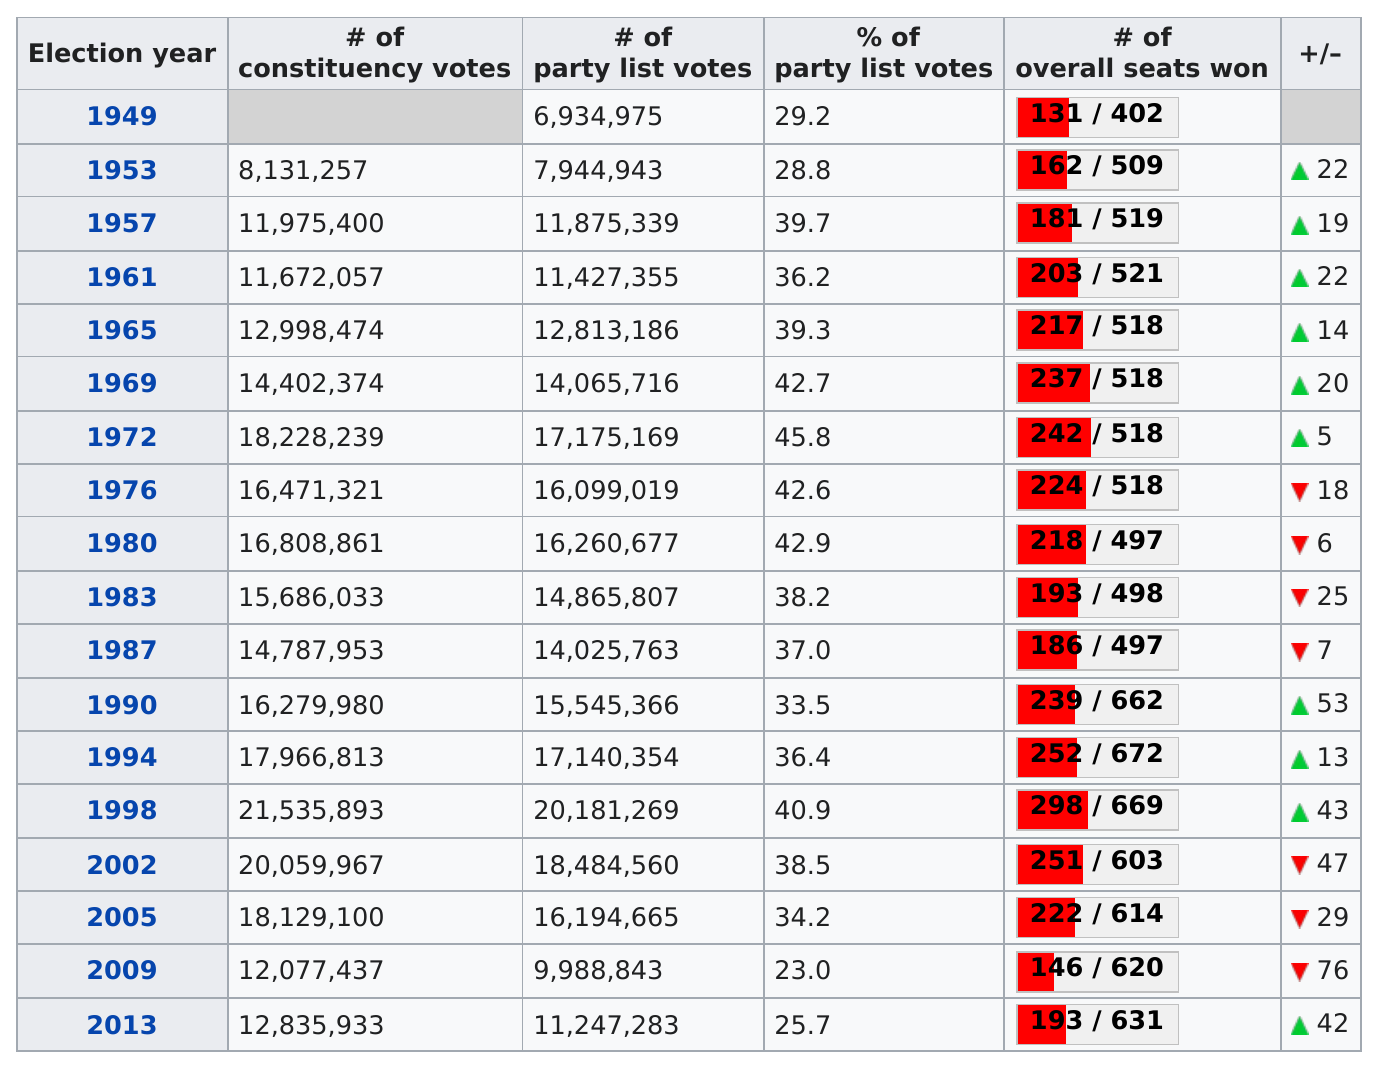Outline some significant characteristics in this image. In 1949, the party that won the least overall seats was the Republican Party. After 1949, there were six consecutive years in which the number of overall seats increased. In 1961, the number of party list votes won was 11,427,355. The Social Democratic Party won at least 14,000 constituency votes in which years? In 2009, the year with fewer votes, 1994 had fewer votes than 2009. 